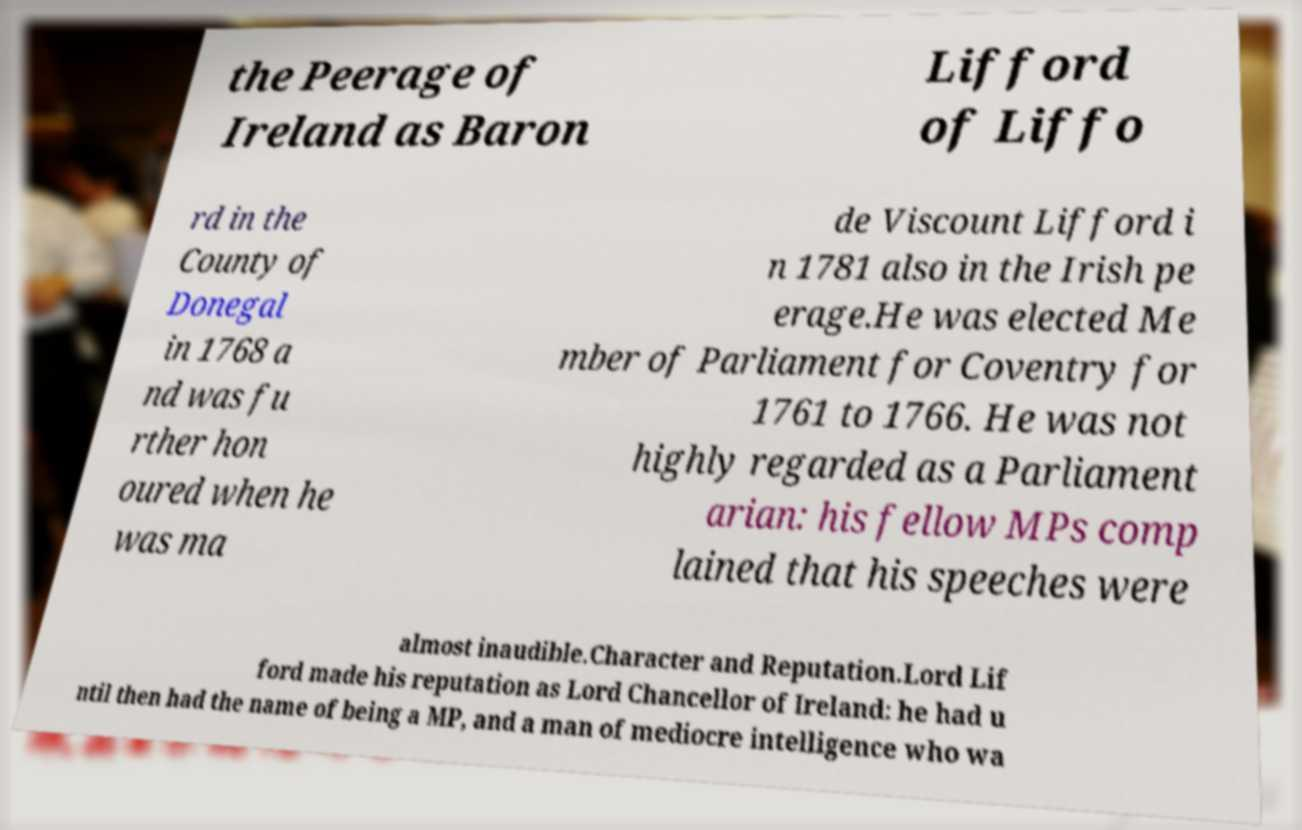Please read and relay the text visible in this image. What does it say? the Peerage of Ireland as Baron Lifford of Liffo rd in the County of Donegal in 1768 a nd was fu rther hon oured when he was ma de Viscount Lifford i n 1781 also in the Irish pe erage.He was elected Me mber of Parliament for Coventry for 1761 to 1766. He was not highly regarded as a Parliament arian: his fellow MPs comp lained that his speeches were almost inaudible.Character and Reputation.Lord Lif ford made his reputation as Lord Chancellor of Ireland: he had u ntil then had the name of being a MP, and a man of mediocre intelligence who wa 